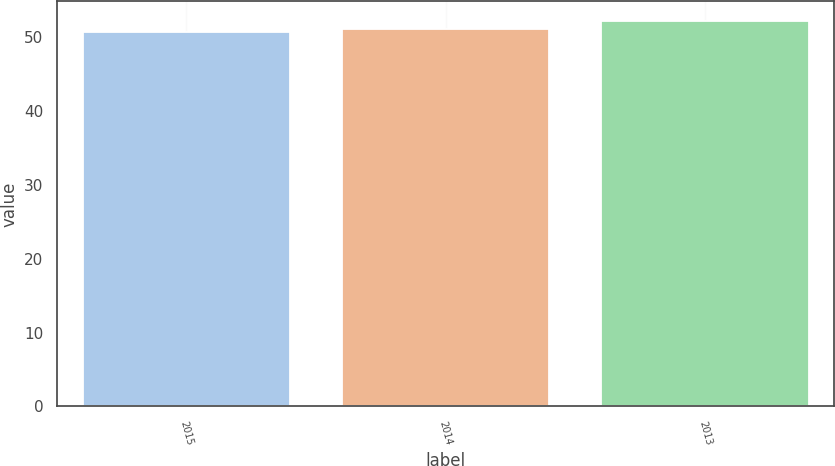<chart> <loc_0><loc_0><loc_500><loc_500><bar_chart><fcel>2015<fcel>2014<fcel>2013<nl><fcel>50.8<fcel>51.2<fcel>52.3<nl></chart> 